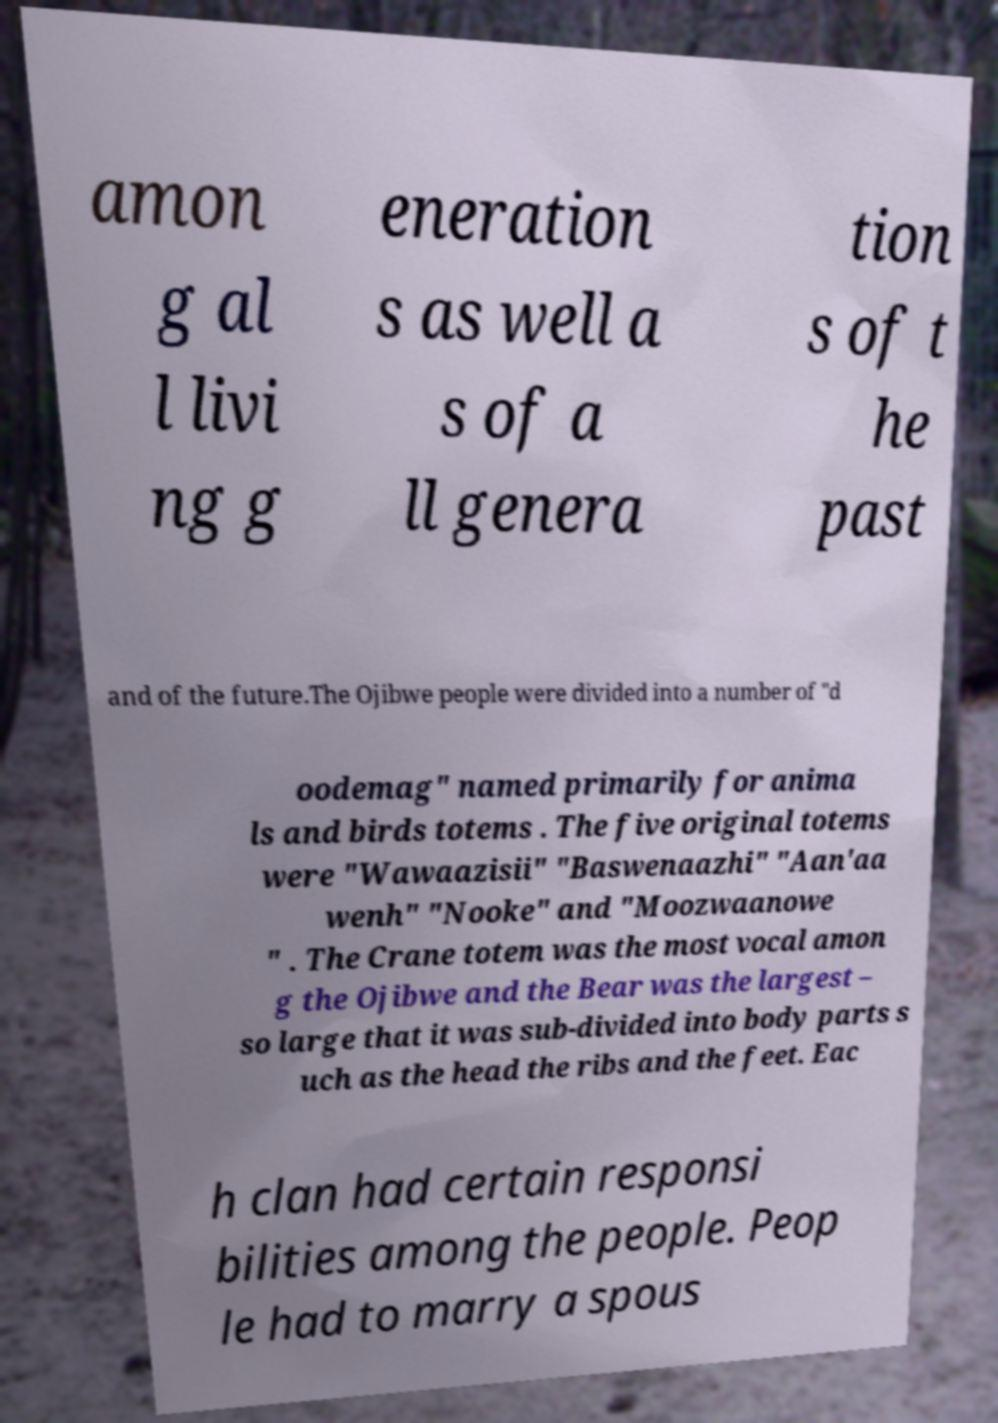Can you read and provide the text displayed in the image?This photo seems to have some interesting text. Can you extract and type it out for me? amon g al l livi ng g eneration s as well a s of a ll genera tion s of t he past and of the future.The Ojibwe people were divided into a number of "d oodemag" named primarily for anima ls and birds totems . The five original totems were "Wawaazisii" "Baswenaazhi" "Aan'aa wenh" "Nooke" and "Moozwaanowe " . The Crane totem was the most vocal amon g the Ojibwe and the Bear was the largest – so large that it was sub-divided into body parts s uch as the head the ribs and the feet. Eac h clan had certain responsi bilities among the people. Peop le had to marry a spous 